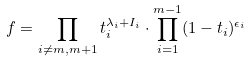Convert formula to latex. <formula><loc_0><loc_0><loc_500><loc_500>f = \prod _ { i \neq m , m + 1 } t _ { i } ^ { \lambda _ { i } + I _ { i } } \cdot \prod _ { i = 1 } ^ { m - 1 } ( 1 - t _ { i } ) ^ { \epsilon _ { i } }</formula> 